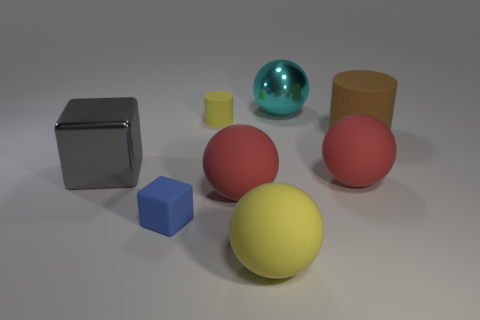How many other things are the same shape as the large cyan metal thing?
Your answer should be compact. 3. The big gray metallic object has what shape?
Your answer should be compact. Cube. What is the color of the other tiny object that is made of the same material as the tiny blue object?
Make the answer very short. Yellow. Is the number of cyan metal spheres greater than the number of red balls?
Offer a terse response. No. Is there a yellow metallic block?
Your answer should be compact. No. There is a blue rubber object that is to the left of the big brown thing right of the tiny matte cylinder; what shape is it?
Your response must be concise. Cube. What number of things are either large purple balls or large balls that are behind the small blue rubber cube?
Keep it short and to the point. 3. What is the color of the cube in front of the large shiny thing left of the big object that is behind the brown cylinder?
Make the answer very short. Blue. There is a gray object that is the same shape as the tiny blue thing; what material is it?
Give a very brief answer. Metal. The big shiny sphere has what color?
Offer a very short reply. Cyan. 